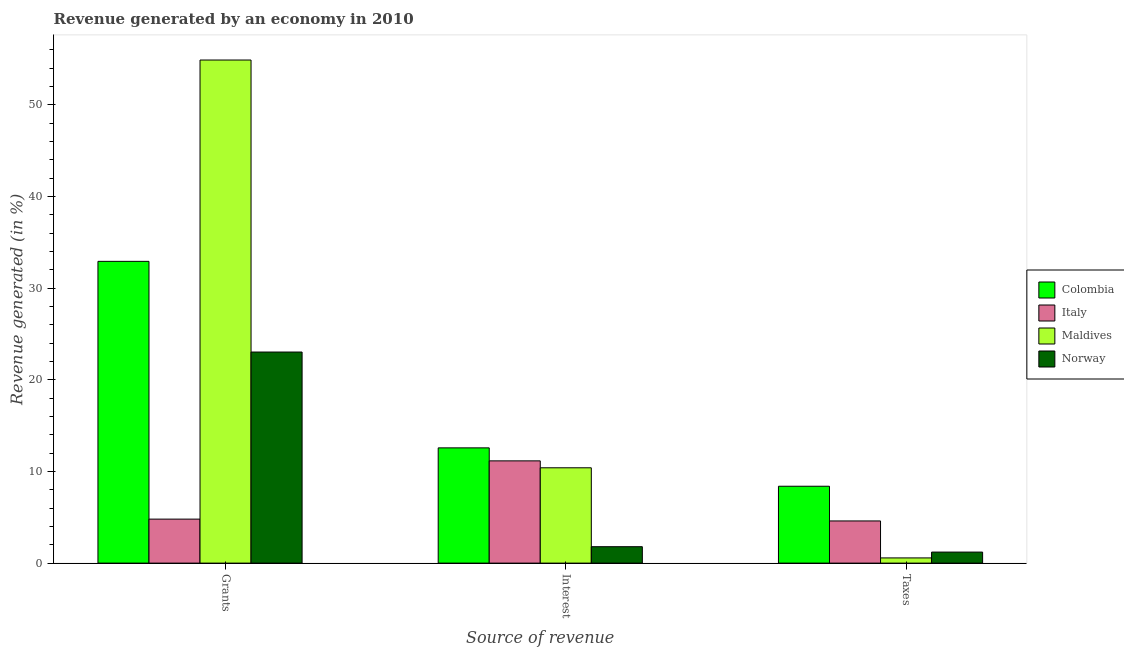How many different coloured bars are there?
Your answer should be very brief. 4. How many bars are there on the 1st tick from the right?
Your answer should be compact. 4. What is the label of the 2nd group of bars from the left?
Give a very brief answer. Interest. What is the percentage of revenue generated by interest in Norway?
Make the answer very short. 1.79. Across all countries, what is the maximum percentage of revenue generated by grants?
Provide a succinct answer. 54.89. Across all countries, what is the minimum percentage of revenue generated by interest?
Offer a very short reply. 1.79. In which country was the percentage of revenue generated by grants minimum?
Your answer should be very brief. Italy. What is the total percentage of revenue generated by grants in the graph?
Keep it short and to the point. 115.64. What is the difference between the percentage of revenue generated by grants in Norway and that in Maldives?
Give a very brief answer. -31.86. What is the difference between the percentage of revenue generated by grants in Colombia and the percentage of revenue generated by taxes in Norway?
Give a very brief answer. 31.72. What is the average percentage of revenue generated by grants per country?
Offer a very short reply. 28.91. What is the difference between the percentage of revenue generated by taxes and percentage of revenue generated by interest in Italy?
Your answer should be compact. -6.55. In how many countries, is the percentage of revenue generated by grants greater than 34 %?
Keep it short and to the point. 1. What is the ratio of the percentage of revenue generated by taxes in Colombia to that in Maldives?
Give a very brief answer. 14.77. What is the difference between the highest and the second highest percentage of revenue generated by grants?
Give a very brief answer. 21.97. What is the difference between the highest and the lowest percentage of revenue generated by grants?
Your answer should be very brief. 50.09. Is it the case that in every country, the sum of the percentage of revenue generated by grants and percentage of revenue generated by interest is greater than the percentage of revenue generated by taxes?
Offer a terse response. Yes. How many bars are there?
Your answer should be compact. 12. Are all the bars in the graph horizontal?
Offer a terse response. No. How many countries are there in the graph?
Provide a short and direct response. 4. What is the difference between two consecutive major ticks on the Y-axis?
Offer a very short reply. 10. Are the values on the major ticks of Y-axis written in scientific E-notation?
Offer a very short reply. No. Does the graph contain any zero values?
Your response must be concise. No. Where does the legend appear in the graph?
Keep it short and to the point. Center right. What is the title of the graph?
Provide a short and direct response. Revenue generated by an economy in 2010. Does "OECD members" appear as one of the legend labels in the graph?
Provide a succinct answer. No. What is the label or title of the X-axis?
Provide a succinct answer. Source of revenue. What is the label or title of the Y-axis?
Give a very brief answer. Revenue generated (in %). What is the Revenue generated (in %) of Colombia in Grants?
Give a very brief answer. 32.92. What is the Revenue generated (in %) of Italy in Grants?
Offer a very short reply. 4.8. What is the Revenue generated (in %) in Maldives in Grants?
Give a very brief answer. 54.89. What is the Revenue generated (in %) in Norway in Grants?
Provide a succinct answer. 23.03. What is the Revenue generated (in %) in Colombia in Interest?
Offer a very short reply. 12.57. What is the Revenue generated (in %) of Italy in Interest?
Make the answer very short. 11.16. What is the Revenue generated (in %) of Maldives in Interest?
Keep it short and to the point. 10.4. What is the Revenue generated (in %) in Norway in Interest?
Your response must be concise. 1.79. What is the Revenue generated (in %) of Colombia in Taxes?
Your response must be concise. 8.39. What is the Revenue generated (in %) of Italy in Taxes?
Your answer should be compact. 4.6. What is the Revenue generated (in %) in Maldives in Taxes?
Ensure brevity in your answer.  0.57. What is the Revenue generated (in %) in Norway in Taxes?
Your answer should be compact. 1.2. Across all Source of revenue, what is the maximum Revenue generated (in %) of Colombia?
Offer a terse response. 32.92. Across all Source of revenue, what is the maximum Revenue generated (in %) of Italy?
Provide a succinct answer. 11.16. Across all Source of revenue, what is the maximum Revenue generated (in %) in Maldives?
Provide a succinct answer. 54.89. Across all Source of revenue, what is the maximum Revenue generated (in %) of Norway?
Provide a succinct answer. 23.03. Across all Source of revenue, what is the minimum Revenue generated (in %) of Colombia?
Your response must be concise. 8.39. Across all Source of revenue, what is the minimum Revenue generated (in %) of Italy?
Make the answer very short. 4.6. Across all Source of revenue, what is the minimum Revenue generated (in %) in Maldives?
Keep it short and to the point. 0.57. Across all Source of revenue, what is the minimum Revenue generated (in %) of Norway?
Your response must be concise. 1.2. What is the total Revenue generated (in %) of Colombia in the graph?
Ensure brevity in your answer.  53.89. What is the total Revenue generated (in %) of Italy in the graph?
Keep it short and to the point. 20.56. What is the total Revenue generated (in %) in Maldives in the graph?
Your answer should be very brief. 65.86. What is the total Revenue generated (in %) in Norway in the graph?
Make the answer very short. 26.02. What is the difference between the Revenue generated (in %) in Colombia in Grants and that in Interest?
Your answer should be compact. 20.35. What is the difference between the Revenue generated (in %) of Italy in Grants and that in Interest?
Offer a terse response. -6.36. What is the difference between the Revenue generated (in %) in Maldives in Grants and that in Interest?
Keep it short and to the point. 44.49. What is the difference between the Revenue generated (in %) of Norway in Grants and that in Interest?
Provide a succinct answer. 21.24. What is the difference between the Revenue generated (in %) of Colombia in Grants and that in Taxes?
Provide a succinct answer. 24.54. What is the difference between the Revenue generated (in %) in Italy in Grants and that in Taxes?
Provide a succinct answer. 0.2. What is the difference between the Revenue generated (in %) in Maldives in Grants and that in Taxes?
Offer a terse response. 54.32. What is the difference between the Revenue generated (in %) of Norway in Grants and that in Taxes?
Provide a short and direct response. 21.83. What is the difference between the Revenue generated (in %) of Colombia in Interest and that in Taxes?
Offer a very short reply. 4.19. What is the difference between the Revenue generated (in %) in Italy in Interest and that in Taxes?
Keep it short and to the point. 6.55. What is the difference between the Revenue generated (in %) in Maldives in Interest and that in Taxes?
Keep it short and to the point. 9.83. What is the difference between the Revenue generated (in %) of Norway in Interest and that in Taxes?
Offer a terse response. 0.59. What is the difference between the Revenue generated (in %) in Colombia in Grants and the Revenue generated (in %) in Italy in Interest?
Your answer should be very brief. 21.77. What is the difference between the Revenue generated (in %) of Colombia in Grants and the Revenue generated (in %) of Maldives in Interest?
Keep it short and to the point. 22.52. What is the difference between the Revenue generated (in %) of Colombia in Grants and the Revenue generated (in %) of Norway in Interest?
Your answer should be very brief. 31.13. What is the difference between the Revenue generated (in %) in Italy in Grants and the Revenue generated (in %) in Maldives in Interest?
Provide a succinct answer. -5.6. What is the difference between the Revenue generated (in %) of Italy in Grants and the Revenue generated (in %) of Norway in Interest?
Ensure brevity in your answer.  3.01. What is the difference between the Revenue generated (in %) in Maldives in Grants and the Revenue generated (in %) in Norway in Interest?
Offer a terse response. 53.1. What is the difference between the Revenue generated (in %) in Colombia in Grants and the Revenue generated (in %) in Italy in Taxes?
Make the answer very short. 28.32. What is the difference between the Revenue generated (in %) in Colombia in Grants and the Revenue generated (in %) in Maldives in Taxes?
Keep it short and to the point. 32.36. What is the difference between the Revenue generated (in %) in Colombia in Grants and the Revenue generated (in %) in Norway in Taxes?
Make the answer very short. 31.72. What is the difference between the Revenue generated (in %) in Italy in Grants and the Revenue generated (in %) in Maldives in Taxes?
Your response must be concise. 4.23. What is the difference between the Revenue generated (in %) of Italy in Grants and the Revenue generated (in %) of Norway in Taxes?
Your answer should be compact. 3.6. What is the difference between the Revenue generated (in %) in Maldives in Grants and the Revenue generated (in %) in Norway in Taxes?
Ensure brevity in your answer.  53.69. What is the difference between the Revenue generated (in %) of Colombia in Interest and the Revenue generated (in %) of Italy in Taxes?
Offer a terse response. 7.97. What is the difference between the Revenue generated (in %) in Colombia in Interest and the Revenue generated (in %) in Maldives in Taxes?
Give a very brief answer. 12.01. What is the difference between the Revenue generated (in %) of Colombia in Interest and the Revenue generated (in %) of Norway in Taxes?
Give a very brief answer. 11.37. What is the difference between the Revenue generated (in %) in Italy in Interest and the Revenue generated (in %) in Maldives in Taxes?
Ensure brevity in your answer.  10.59. What is the difference between the Revenue generated (in %) in Italy in Interest and the Revenue generated (in %) in Norway in Taxes?
Offer a very short reply. 9.95. What is the difference between the Revenue generated (in %) of Maldives in Interest and the Revenue generated (in %) of Norway in Taxes?
Offer a terse response. 9.2. What is the average Revenue generated (in %) in Colombia per Source of revenue?
Your answer should be compact. 17.96. What is the average Revenue generated (in %) in Italy per Source of revenue?
Provide a succinct answer. 6.85. What is the average Revenue generated (in %) of Maldives per Source of revenue?
Provide a short and direct response. 21.95. What is the average Revenue generated (in %) of Norway per Source of revenue?
Offer a very short reply. 8.67. What is the difference between the Revenue generated (in %) of Colombia and Revenue generated (in %) of Italy in Grants?
Your response must be concise. 28.12. What is the difference between the Revenue generated (in %) in Colombia and Revenue generated (in %) in Maldives in Grants?
Give a very brief answer. -21.97. What is the difference between the Revenue generated (in %) in Colombia and Revenue generated (in %) in Norway in Grants?
Ensure brevity in your answer.  9.89. What is the difference between the Revenue generated (in %) of Italy and Revenue generated (in %) of Maldives in Grants?
Provide a short and direct response. -50.09. What is the difference between the Revenue generated (in %) of Italy and Revenue generated (in %) of Norway in Grants?
Offer a terse response. -18.23. What is the difference between the Revenue generated (in %) of Maldives and Revenue generated (in %) of Norway in Grants?
Provide a short and direct response. 31.86. What is the difference between the Revenue generated (in %) in Colombia and Revenue generated (in %) in Italy in Interest?
Provide a succinct answer. 1.42. What is the difference between the Revenue generated (in %) in Colombia and Revenue generated (in %) in Maldives in Interest?
Provide a short and direct response. 2.17. What is the difference between the Revenue generated (in %) in Colombia and Revenue generated (in %) in Norway in Interest?
Make the answer very short. 10.78. What is the difference between the Revenue generated (in %) of Italy and Revenue generated (in %) of Maldives in Interest?
Keep it short and to the point. 0.75. What is the difference between the Revenue generated (in %) in Italy and Revenue generated (in %) in Norway in Interest?
Your answer should be compact. 9.36. What is the difference between the Revenue generated (in %) of Maldives and Revenue generated (in %) of Norway in Interest?
Ensure brevity in your answer.  8.61. What is the difference between the Revenue generated (in %) of Colombia and Revenue generated (in %) of Italy in Taxes?
Give a very brief answer. 3.79. What is the difference between the Revenue generated (in %) in Colombia and Revenue generated (in %) in Maldives in Taxes?
Make the answer very short. 7.82. What is the difference between the Revenue generated (in %) of Colombia and Revenue generated (in %) of Norway in Taxes?
Your response must be concise. 7.18. What is the difference between the Revenue generated (in %) in Italy and Revenue generated (in %) in Maldives in Taxes?
Offer a very short reply. 4.03. What is the difference between the Revenue generated (in %) in Italy and Revenue generated (in %) in Norway in Taxes?
Your answer should be very brief. 3.4. What is the difference between the Revenue generated (in %) in Maldives and Revenue generated (in %) in Norway in Taxes?
Offer a very short reply. -0.64. What is the ratio of the Revenue generated (in %) of Colombia in Grants to that in Interest?
Give a very brief answer. 2.62. What is the ratio of the Revenue generated (in %) in Italy in Grants to that in Interest?
Make the answer very short. 0.43. What is the ratio of the Revenue generated (in %) of Maldives in Grants to that in Interest?
Give a very brief answer. 5.28. What is the ratio of the Revenue generated (in %) of Norway in Grants to that in Interest?
Make the answer very short. 12.86. What is the ratio of the Revenue generated (in %) in Colombia in Grants to that in Taxes?
Your answer should be very brief. 3.93. What is the ratio of the Revenue generated (in %) in Italy in Grants to that in Taxes?
Give a very brief answer. 1.04. What is the ratio of the Revenue generated (in %) of Maldives in Grants to that in Taxes?
Keep it short and to the point. 96.65. What is the ratio of the Revenue generated (in %) of Norway in Grants to that in Taxes?
Provide a short and direct response. 19.14. What is the ratio of the Revenue generated (in %) of Colombia in Interest to that in Taxes?
Your answer should be very brief. 1.5. What is the ratio of the Revenue generated (in %) of Italy in Interest to that in Taxes?
Offer a terse response. 2.42. What is the ratio of the Revenue generated (in %) in Maldives in Interest to that in Taxes?
Provide a succinct answer. 18.31. What is the ratio of the Revenue generated (in %) in Norway in Interest to that in Taxes?
Ensure brevity in your answer.  1.49. What is the difference between the highest and the second highest Revenue generated (in %) in Colombia?
Offer a terse response. 20.35. What is the difference between the highest and the second highest Revenue generated (in %) of Italy?
Your response must be concise. 6.36. What is the difference between the highest and the second highest Revenue generated (in %) of Maldives?
Your answer should be very brief. 44.49. What is the difference between the highest and the second highest Revenue generated (in %) in Norway?
Provide a succinct answer. 21.24. What is the difference between the highest and the lowest Revenue generated (in %) in Colombia?
Give a very brief answer. 24.54. What is the difference between the highest and the lowest Revenue generated (in %) in Italy?
Offer a terse response. 6.55. What is the difference between the highest and the lowest Revenue generated (in %) of Maldives?
Provide a succinct answer. 54.32. What is the difference between the highest and the lowest Revenue generated (in %) of Norway?
Offer a terse response. 21.83. 